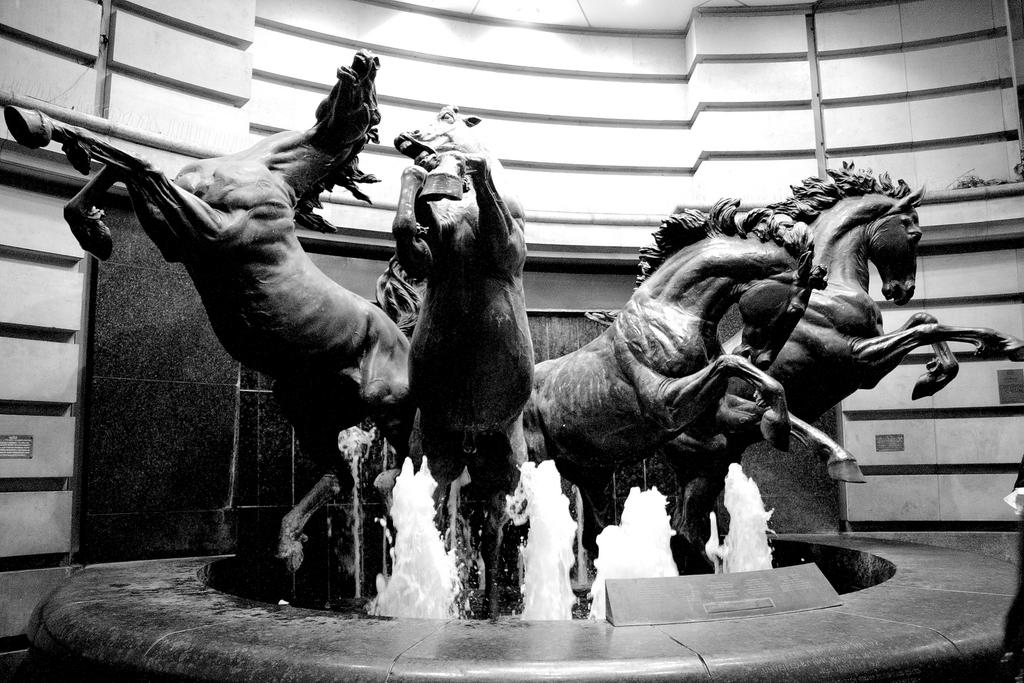What is the color scheme of the image? The image is black and white. What is the main subject in the center of the image? There is a fountain in the center of the image. What other objects can be seen in the image? There are sculptures in the image. What is visible in the background of the image? There is a wall in the background of the image. How many people are in the crowd surrounding the fountain in the image? There is no crowd present in the image; it only features a fountain and sculptures. What type of twist can be seen in the sculptures in the image? There is no twist visible in the sculptures in the image; they are not described as having any specific shapes or forms. 